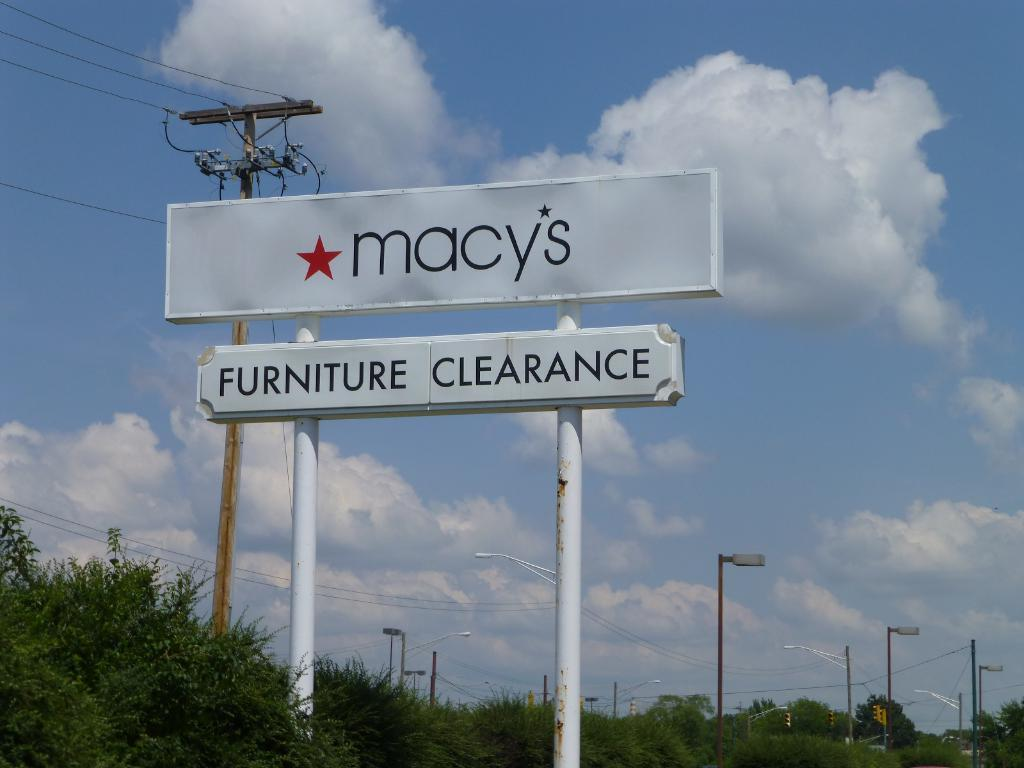<image>
Render a clear and concise summary of the photo. A road sign for Macy's that advertises furniture clearance 